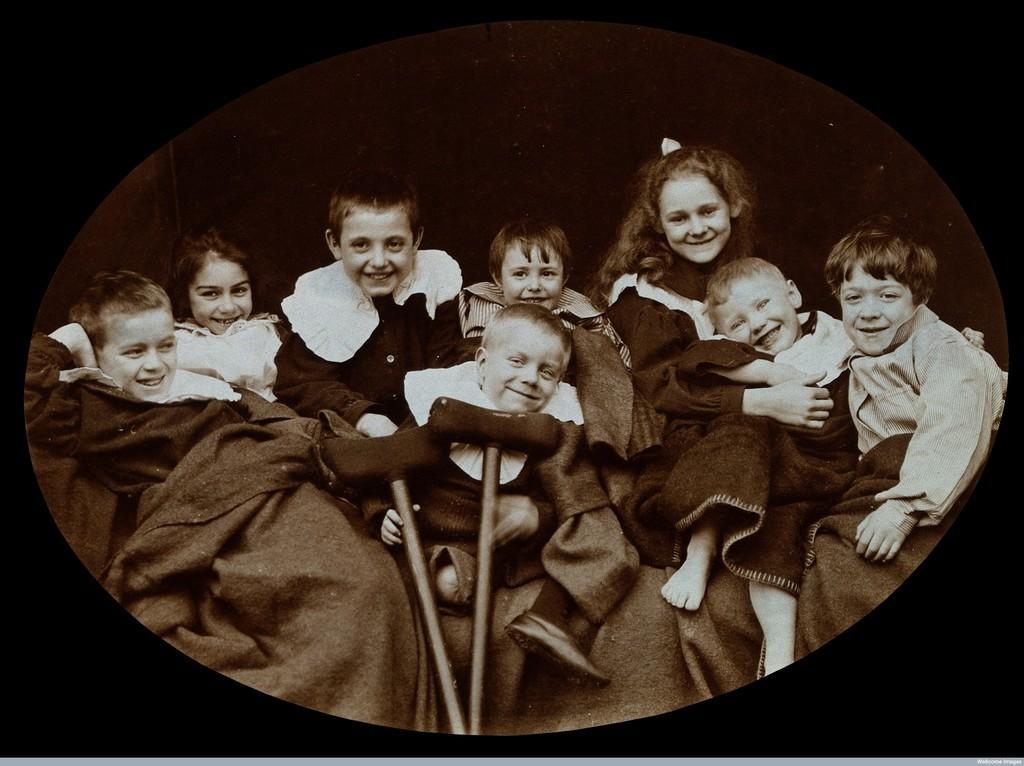Can you describe this image briefly? There are group of children, smiling and sitting on an object. The background is dark in color. 